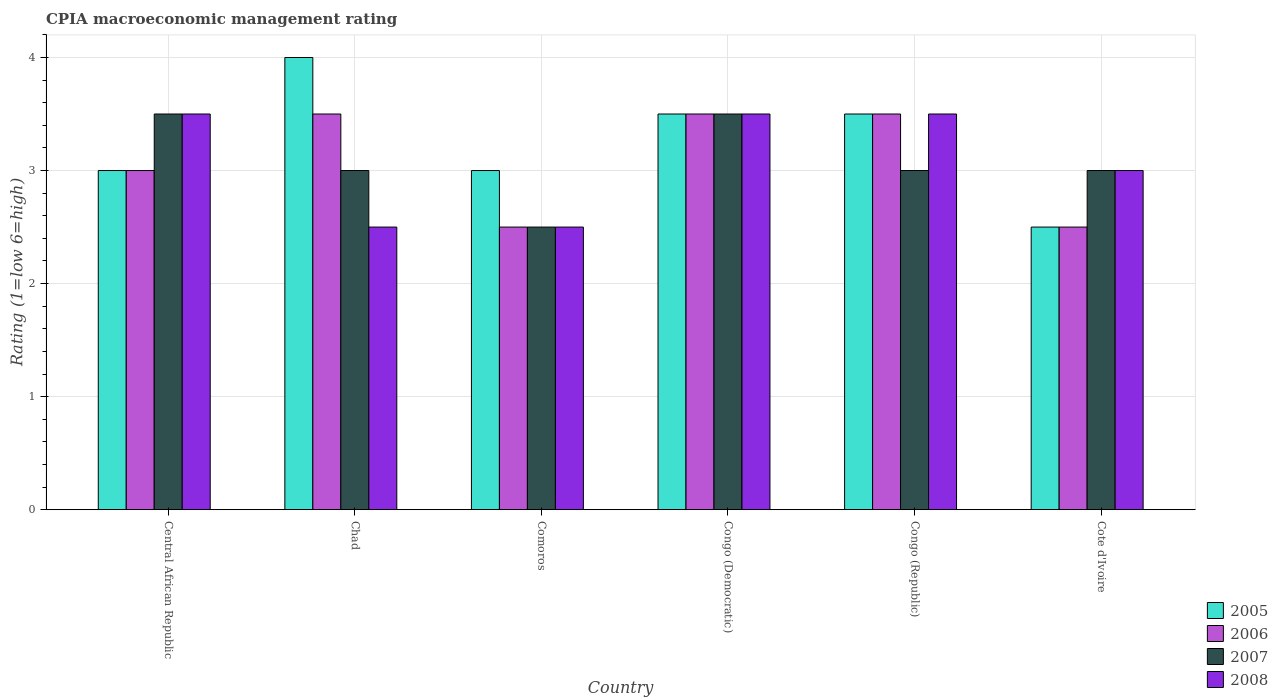Are the number of bars per tick equal to the number of legend labels?
Offer a terse response. Yes. Are the number of bars on each tick of the X-axis equal?
Offer a very short reply. Yes. How many bars are there on the 5th tick from the left?
Keep it short and to the point. 4. What is the label of the 2nd group of bars from the left?
Offer a very short reply. Chad. In how many cases, is the number of bars for a given country not equal to the number of legend labels?
Ensure brevity in your answer.  0. What is the CPIA rating in 2008 in Central African Republic?
Your response must be concise. 3.5. Across all countries, what is the minimum CPIA rating in 2005?
Provide a succinct answer. 2.5. In which country was the CPIA rating in 2005 maximum?
Offer a terse response. Chad. In which country was the CPIA rating in 2006 minimum?
Ensure brevity in your answer.  Comoros. What is the total CPIA rating in 2007 in the graph?
Offer a very short reply. 18.5. What is the average CPIA rating in 2005 per country?
Offer a very short reply. 3.25. In how many countries, is the CPIA rating in 2008 greater than 1?
Your answer should be compact. 6. What is the ratio of the CPIA rating in 2005 in Congo (Democratic) to that in Cote d'Ivoire?
Make the answer very short. 1.4. Is the CPIA rating in 2005 in Chad less than that in Comoros?
Provide a succinct answer. No. Is the difference between the CPIA rating in 2007 in Chad and Congo (Republic) greater than the difference between the CPIA rating in 2006 in Chad and Congo (Republic)?
Make the answer very short. No. Is it the case that in every country, the sum of the CPIA rating in 2007 and CPIA rating in 2008 is greater than the sum of CPIA rating in 2005 and CPIA rating in 2006?
Make the answer very short. No. What does the 2nd bar from the left in Congo (Democratic) represents?
Keep it short and to the point. 2006. What does the 4th bar from the right in Cote d'Ivoire represents?
Keep it short and to the point. 2005. Is it the case that in every country, the sum of the CPIA rating in 2006 and CPIA rating in 2008 is greater than the CPIA rating in 2007?
Provide a succinct answer. Yes. How many bars are there?
Keep it short and to the point. 24. How many countries are there in the graph?
Provide a succinct answer. 6. Are the values on the major ticks of Y-axis written in scientific E-notation?
Offer a terse response. No. Does the graph contain any zero values?
Your answer should be compact. No. Does the graph contain grids?
Your answer should be compact. Yes. How many legend labels are there?
Keep it short and to the point. 4. What is the title of the graph?
Provide a short and direct response. CPIA macroeconomic management rating. What is the Rating (1=low 6=high) in 2008 in Central African Republic?
Provide a short and direct response. 3.5. What is the Rating (1=low 6=high) in 2005 in Chad?
Provide a succinct answer. 4. What is the Rating (1=low 6=high) of 2006 in Chad?
Provide a succinct answer. 3.5. What is the Rating (1=low 6=high) of 2008 in Chad?
Give a very brief answer. 2.5. What is the Rating (1=low 6=high) of 2005 in Comoros?
Keep it short and to the point. 3. What is the Rating (1=low 6=high) in 2007 in Comoros?
Give a very brief answer. 2.5. What is the Rating (1=low 6=high) in 2008 in Congo (Democratic)?
Offer a terse response. 3.5. What is the Rating (1=low 6=high) in 2005 in Congo (Republic)?
Offer a terse response. 3.5. What is the Rating (1=low 6=high) of 2008 in Congo (Republic)?
Provide a succinct answer. 3.5. What is the Rating (1=low 6=high) of 2005 in Cote d'Ivoire?
Your answer should be compact. 2.5. What is the Rating (1=low 6=high) of 2006 in Cote d'Ivoire?
Your response must be concise. 2.5. What is the Rating (1=low 6=high) in 2007 in Cote d'Ivoire?
Offer a very short reply. 3. Across all countries, what is the maximum Rating (1=low 6=high) of 2007?
Ensure brevity in your answer.  3.5. Across all countries, what is the maximum Rating (1=low 6=high) of 2008?
Provide a succinct answer. 3.5. Across all countries, what is the minimum Rating (1=low 6=high) of 2006?
Make the answer very short. 2.5. Across all countries, what is the minimum Rating (1=low 6=high) in 2007?
Keep it short and to the point. 2.5. Across all countries, what is the minimum Rating (1=low 6=high) of 2008?
Give a very brief answer. 2.5. What is the difference between the Rating (1=low 6=high) in 2005 in Central African Republic and that in Comoros?
Give a very brief answer. 0. What is the difference between the Rating (1=low 6=high) of 2006 in Central African Republic and that in Comoros?
Ensure brevity in your answer.  0.5. What is the difference between the Rating (1=low 6=high) in 2007 in Central African Republic and that in Comoros?
Provide a short and direct response. 1. What is the difference between the Rating (1=low 6=high) of 2005 in Central African Republic and that in Congo (Democratic)?
Keep it short and to the point. -0.5. What is the difference between the Rating (1=low 6=high) of 2007 in Central African Republic and that in Congo (Democratic)?
Ensure brevity in your answer.  0. What is the difference between the Rating (1=low 6=high) in 2006 in Central African Republic and that in Congo (Republic)?
Keep it short and to the point. -0.5. What is the difference between the Rating (1=low 6=high) of 2007 in Central African Republic and that in Congo (Republic)?
Provide a succinct answer. 0.5. What is the difference between the Rating (1=low 6=high) of 2008 in Central African Republic and that in Congo (Republic)?
Your answer should be compact. 0. What is the difference between the Rating (1=low 6=high) of 2005 in Chad and that in Comoros?
Your answer should be very brief. 1. What is the difference between the Rating (1=low 6=high) in 2006 in Chad and that in Comoros?
Make the answer very short. 1. What is the difference between the Rating (1=low 6=high) in 2007 in Chad and that in Comoros?
Provide a succinct answer. 0.5. What is the difference between the Rating (1=low 6=high) in 2006 in Chad and that in Congo (Democratic)?
Your answer should be compact. 0. What is the difference between the Rating (1=low 6=high) in 2007 in Chad and that in Congo (Democratic)?
Keep it short and to the point. -0.5. What is the difference between the Rating (1=low 6=high) of 2005 in Chad and that in Congo (Republic)?
Make the answer very short. 0.5. What is the difference between the Rating (1=low 6=high) in 2007 in Chad and that in Congo (Republic)?
Provide a short and direct response. 0. What is the difference between the Rating (1=low 6=high) in 2006 in Chad and that in Cote d'Ivoire?
Offer a terse response. 1. What is the difference between the Rating (1=low 6=high) in 2006 in Comoros and that in Congo (Democratic)?
Provide a short and direct response. -1. What is the difference between the Rating (1=low 6=high) of 2007 in Comoros and that in Congo (Democratic)?
Offer a very short reply. -1. What is the difference between the Rating (1=low 6=high) in 2005 in Comoros and that in Congo (Republic)?
Provide a succinct answer. -0.5. What is the difference between the Rating (1=low 6=high) of 2006 in Comoros and that in Congo (Republic)?
Provide a succinct answer. -1. What is the difference between the Rating (1=low 6=high) of 2008 in Comoros and that in Congo (Republic)?
Ensure brevity in your answer.  -1. What is the difference between the Rating (1=low 6=high) of 2007 in Comoros and that in Cote d'Ivoire?
Keep it short and to the point. -0.5. What is the difference between the Rating (1=low 6=high) in 2008 in Congo (Democratic) and that in Congo (Republic)?
Your response must be concise. 0. What is the difference between the Rating (1=low 6=high) in 2005 in Congo (Democratic) and that in Cote d'Ivoire?
Keep it short and to the point. 1. What is the difference between the Rating (1=low 6=high) of 2007 in Congo (Democratic) and that in Cote d'Ivoire?
Your response must be concise. 0.5. What is the difference between the Rating (1=low 6=high) of 2005 in Congo (Republic) and that in Cote d'Ivoire?
Ensure brevity in your answer.  1. What is the difference between the Rating (1=low 6=high) of 2007 in Congo (Republic) and that in Cote d'Ivoire?
Provide a short and direct response. 0. What is the difference between the Rating (1=low 6=high) in 2008 in Congo (Republic) and that in Cote d'Ivoire?
Keep it short and to the point. 0.5. What is the difference between the Rating (1=low 6=high) in 2005 in Central African Republic and the Rating (1=low 6=high) in 2008 in Chad?
Ensure brevity in your answer.  0.5. What is the difference between the Rating (1=low 6=high) of 2007 in Central African Republic and the Rating (1=low 6=high) of 2008 in Chad?
Your response must be concise. 1. What is the difference between the Rating (1=low 6=high) in 2005 in Central African Republic and the Rating (1=low 6=high) in 2007 in Comoros?
Your answer should be very brief. 0.5. What is the difference between the Rating (1=low 6=high) in 2006 in Central African Republic and the Rating (1=low 6=high) in 2008 in Comoros?
Keep it short and to the point. 0.5. What is the difference between the Rating (1=low 6=high) in 2007 in Central African Republic and the Rating (1=low 6=high) in 2008 in Comoros?
Keep it short and to the point. 1. What is the difference between the Rating (1=low 6=high) of 2005 in Central African Republic and the Rating (1=low 6=high) of 2006 in Congo (Democratic)?
Your answer should be very brief. -0.5. What is the difference between the Rating (1=low 6=high) in 2005 in Central African Republic and the Rating (1=low 6=high) in 2007 in Congo (Democratic)?
Keep it short and to the point. -0.5. What is the difference between the Rating (1=low 6=high) in 2005 in Central African Republic and the Rating (1=low 6=high) in 2006 in Congo (Republic)?
Your answer should be very brief. -0.5. What is the difference between the Rating (1=low 6=high) in 2005 in Central African Republic and the Rating (1=low 6=high) in 2007 in Congo (Republic)?
Your response must be concise. 0. What is the difference between the Rating (1=low 6=high) of 2005 in Central African Republic and the Rating (1=low 6=high) of 2008 in Congo (Republic)?
Provide a short and direct response. -0.5. What is the difference between the Rating (1=low 6=high) in 2006 in Central African Republic and the Rating (1=low 6=high) in 2007 in Congo (Republic)?
Keep it short and to the point. 0. What is the difference between the Rating (1=low 6=high) in 2006 in Central African Republic and the Rating (1=low 6=high) in 2008 in Congo (Republic)?
Keep it short and to the point. -0.5. What is the difference between the Rating (1=low 6=high) in 2005 in Central African Republic and the Rating (1=low 6=high) in 2006 in Cote d'Ivoire?
Keep it short and to the point. 0.5. What is the difference between the Rating (1=low 6=high) in 2005 in Central African Republic and the Rating (1=low 6=high) in 2007 in Cote d'Ivoire?
Your response must be concise. 0. What is the difference between the Rating (1=low 6=high) of 2006 in Central African Republic and the Rating (1=low 6=high) of 2008 in Cote d'Ivoire?
Keep it short and to the point. 0. What is the difference between the Rating (1=low 6=high) in 2007 in Central African Republic and the Rating (1=low 6=high) in 2008 in Cote d'Ivoire?
Give a very brief answer. 0.5. What is the difference between the Rating (1=low 6=high) in 2005 in Chad and the Rating (1=low 6=high) in 2006 in Comoros?
Your answer should be very brief. 1.5. What is the difference between the Rating (1=low 6=high) in 2006 in Chad and the Rating (1=low 6=high) in 2008 in Comoros?
Your answer should be compact. 1. What is the difference between the Rating (1=low 6=high) of 2007 in Chad and the Rating (1=low 6=high) of 2008 in Comoros?
Provide a short and direct response. 0.5. What is the difference between the Rating (1=low 6=high) of 2005 in Chad and the Rating (1=low 6=high) of 2007 in Congo (Democratic)?
Provide a short and direct response. 0.5. What is the difference between the Rating (1=low 6=high) in 2006 in Chad and the Rating (1=low 6=high) in 2007 in Congo (Democratic)?
Your response must be concise. 0. What is the difference between the Rating (1=low 6=high) of 2007 in Chad and the Rating (1=low 6=high) of 2008 in Congo (Democratic)?
Offer a very short reply. -0.5. What is the difference between the Rating (1=low 6=high) of 2007 in Chad and the Rating (1=low 6=high) of 2008 in Congo (Republic)?
Make the answer very short. -0.5. What is the difference between the Rating (1=low 6=high) of 2005 in Chad and the Rating (1=low 6=high) of 2006 in Cote d'Ivoire?
Your response must be concise. 1.5. What is the difference between the Rating (1=low 6=high) in 2007 in Chad and the Rating (1=low 6=high) in 2008 in Cote d'Ivoire?
Keep it short and to the point. 0. What is the difference between the Rating (1=low 6=high) of 2005 in Comoros and the Rating (1=low 6=high) of 2007 in Congo (Democratic)?
Ensure brevity in your answer.  -0.5. What is the difference between the Rating (1=low 6=high) in 2006 in Comoros and the Rating (1=low 6=high) in 2008 in Congo (Democratic)?
Your answer should be very brief. -1. What is the difference between the Rating (1=low 6=high) in 2005 in Comoros and the Rating (1=low 6=high) in 2007 in Congo (Republic)?
Provide a succinct answer. 0. What is the difference between the Rating (1=low 6=high) of 2006 in Comoros and the Rating (1=low 6=high) of 2008 in Congo (Republic)?
Provide a short and direct response. -1. What is the difference between the Rating (1=low 6=high) of 2007 in Comoros and the Rating (1=low 6=high) of 2008 in Congo (Republic)?
Offer a very short reply. -1. What is the difference between the Rating (1=low 6=high) of 2005 in Comoros and the Rating (1=low 6=high) of 2007 in Cote d'Ivoire?
Keep it short and to the point. 0. What is the difference between the Rating (1=low 6=high) of 2005 in Comoros and the Rating (1=low 6=high) of 2008 in Cote d'Ivoire?
Your answer should be very brief. 0. What is the difference between the Rating (1=low 6=high) of 2006 in Comoros and the Rating (1=low 6=high) of 2007 in Cote d'Ivoire?
Your answer should be compact. -0.5. What is the difference between the Rating (1=low 6=high) in 2006 in Comoros and the Rating (1=low 6=high) in 2008 in Cote d'Ivoire?
Provide a short and direct response. -0.5. What is the difference between the Rating (1=low 6=high) in 2005 in Congo (Democratic) and the Rating (1=low 6=high) in 2006 in Congo (Republic)?
Keep it short and to the point. 0. What is the difference between the Rating (1=low 6=high) in 2005 in Congo (Democratic) and the Rating (1=low 6=high) in 2008 in Congo (Republic)?
Your answer should be very brief. 0. What is the difference between the Rating (1=low 6=high) of 2007 in Congo (Democratic) and the Rating (1=low 6=high) of 2008 in Congo (Republic)?
Offer a terse response. 0. What is the difference between the Rating (1=low 6=high) in 2005 in Congo (Democratic) and the Rating (1=low 6=high) in 2006 in Cote d'Ivoire?
Keep it short and to the point. 1. What is the difference between the Rating (1=low 6=high) in 2005 in Congo (Republic) and the Rating (1=low 6=high) in 2006 in Cote d'Ivoire?
Your response must be concise. 1. What is the difference between the Rating (1=low 6=high) of 2006 in Congo (Republic) and the Rating (1=low 6=high) of 2007 in Cote d'Ivoire?
Your response must be concise. 0.5. What is the difference between the Rating (1=low 6=high) in 2006 in Congo (Republic) and the Rating (1=low 6=high) in 2008 in Cote d'Ivoire?
Offer a terse response. 0.5. What is the difference between the Rating (1=low 6=high) in 2007 in Congo (Republic) and the Rating (1=low 6=high) in 2008 in Cote d'Ivoire?
Keep it short and to the point. 0. What is the average Rating (1=low 6=high) in 2006 per country?
Provide a succinct answer. 3.08. What is the average Rating (1=low 6=high) in 2007 per country?
Your answer should be compact. 3.08. What is the average Rating (1=low 6=high) of 2008 per country?
Your response must be concise. 3.08. What is the difference between the Rating (1=low 6=high) in 2005 and Rating (1=low 6=high) in 2006 in Central African Republic?
Offer a very short reply. 0. What is the difference between the Rating (1=low 6=high) of 2005 and Rating (1=low 6=high) of 2008 in Central African Republic?
Give a very brief answer. -0.5. What is the difference between the Rating (1=low 6=high) in 2006 and Rating (1=low 6=high) in 2007 in Central African Republic?
Make the answer very short. -0.5. What is the difference between the Rating (1=low 6=high) of 2006 and Rating (1=low 6=high) of 2008 in Central African Republic?
Your answer should be very brief. -0.5. What is the difference between the Rating (1=low 6=high) in 2007 and Rating (1=low 6=high) in 2008 in Central African Republic?
Keep it short and to the point. 0. What is the difference between the Rating (1=low 6=high) in 2005 and Rating (1=low 6=high) in 2006 in Chad?
Make the answer very short. 0.5. What is the difference between the Rating (1=low 6=high) of 2005 and Rating (1=low 6=high) of 2008 in Chad?
Provide a succinct answer. 1.5. What is the difference between the Rating (1=low 6=high) in 2006 and Rating (1=low 6=high) in 2008 in Chad?
Offer a very short reply. 1. What is the difference between the Rating (1=low 6=high) of 2005 and Rating (1=low 6=high) of 2006 in Comoros?
Your answer should be very brief. 0.5. What is the difference between the Rating (1=low 6=high) in 2005 and Rating (1=low 6=high) in 2007 in Comoros?
Ensure brevity in your answer.  0.5. What is the difference between the Rating (1=low 6=high) in 2006 and Rating (1=low 6=high) in 2007 in Comoros?
Provide a succinct answer. 0. What is the difference between the Rating (1=low 6=high) in 2005 and Rating (1=low 6=high) in 2006 in Congo (Democratic)?
Make the answer very short. 0. What is the difference between the Rating (1=low 6=high) of 2005 and Rating (1=low 6=high) of 2007 in Congo (Democratic)?
Your answer should be compact. 0. What is the difference between the Rating (1=low 6=high) in 2006 and Rating (1=low 6=high) in 2008 in Congo (Democratic)?
Your answer should be very brief. 0. What is the difference between the Rating (1=low 6=high) in 2006 and Rating (1=low 6=high) in 2007 in Congo (Republic)?
Offer a very short reply. 0.5. What is the difference between the Rating (1=low 6=high) in 2007 and Rating (1=low 6=high) in 2008 in Congo (Republic)?
Your answer should be compact. -0.5. What is the difference between the Rating (1=low 6=high) of 2005 and Rating (1=low 6=high) of 2007 in Cote d'Ivoire?
Provide a short and direct response. -0.5. What is the difference between the Rating (1=low 6=high) of 2006 and Rating (1=low 6=high) of 2007 in Cote d'Ivoire?
Make the answer very short. -0.5. What is the difference between the Rating (1=low 6=high) of 2006 and Rating (1=low 6=high) of 2008 in Cote d'Ivoire?
Provide a succinct answer. -0.5. What is the difference between the Rating (1=low 6=high) of 2007 and Rating (1=low 6=high) of 2008 in Cote d'Ivoire?
Your answer should be compact. 0. What is the ratio of the Rating (1=low 6=high) of 2006 in Central African Republic to that in Chad?
Ensure brevity in your answer.  0.86. What is the ratio of the Rating (1=low 6=high) in 2008 in Central African Republic to that in Chad?
Give a very brief answer. 1.4. What is the ratio of the Rating (1=low 6=high) in 2006 in Central African Republic to that in Comoros?
Ensure brevity in your answer.  1.2. What is the ratio of the Rating (1=low 6=high) of 2008 in Central African Republic to that in Comoros?
Your answer should be compact. 1.4. What is the ratio of the Rating (1=low 6=high) of 2005 in Central African Republic to that in Congo (Democratic)?
Your response must be concise. 0.86. What is the ratio of the Rating (1=low 6=high) of 2006 in Central African Republic to that in Congo (Democratic)?
Your answer should be compact. 0.86. What is the ratio of the Rating (1=low 6=high) of 2005 in Central African Republic to that in Congo (Republic)?
Keep it short and to the point. 0.86. What is the ratio of the Rating (1=low 6=high) in 2007 in Central African Republic to that in Congo (Republic)?
Make the answer very short. 1.17. What is the ratio of the Rating (1=low 6=high) in 2006 in Central African Republic to that in Cote d'Ivoire?
Offer a very short reply. 1.2. What is the ratio of the Rating (1=low 6=high) of 2007 in Central African Republic to that in Cote d'Ivoire?
Your answer should be compact. 1.17. What is the ratio of the Rating (1=low 6=high) in 2005 in Chad to that in Comoros?
Provide a succinct answer. 1.33. What is the ratio of the Rating (1=low 6=high) of 2007 in Chad to that in Comoros?
Keep it short and to the point. 1.2. What is the ratio of the Rating (1=low 6=high) of 2008 in Chad to that in Comoros?
Provide a succinct answer. 1. What is the ratio of the Rating (1=low 6=high) of 2007 in Chad to that in Congo (Democratic)?
Offer a terse response. 0.86. What is the ratio of the Rating (1=low 6=high) in 2008 in Chad to that in Congo (Democratic)?
Your response must be concise. 0.71. What is the ratio of the Rating (1=low 6=high) in 2006 in Chad to that in Congo (Republic)?
Ensure brevity in your answer.  1. What is the ratio of the Rating (1=low 6=high) of 2007 in Chad to that in Cote d'Ivoire?
Ensure brevity in your answer.  1. What is the ratio of the Rating (1=low 6=high) in 2005 in Comoros to that in Congo (Democratic)?
Offer a very short reply. 0.86. What is the ratio of the Rating (1=low 6=high) of 2006 in Comoros to that in Congo (Democratic)?
Provide a short and direct response. 0.71. What is the ratio of the Rating (1=low 6=high) of 2006 in Comoros to that in Congo (Republic)?
Offer a terse response. 0.71. What is the ratio of the Rating (1=low 6=high) in 2007 in Comoros to that in Congo (Republic)?
Provide a short and direct response. 0.83. What is the ratio of the Rating (1=low 6=high) of 2006 in Comoros to that in Cote d'Ivoire?
Offer a very short reply. 1. What is the ratio of the Rating (1=low 6=high) of 2007 in Comoros to that in Cote d'Ivoire?
Provide a short and direct response. 0.83. What is the ratio of the Rating (1=low 6=high) in 2005 in Congo (Democratic) to that in Congo (Republic)?
Your answer should be very brief. 1. What is the ratio of the Rating (1=low 6=high) of 2006 in Congo (Democratic) to that in Congo (Republic)?
Offer a very short reply. 1. What is the ratio of the Rating (1=low 6=high) in 2007 in Congo (Democratic) to that in Congo (Republic)?
Offer a terse response. 1.17. What is the ratio of the Rating (1=low 6=high) of 2008 in Congo (Democratic) to that in Cote d'Ivoire?
Your response must be concise. 1.17. What is the ratio of the Rating (1=low 6=high) in 2006 in Congo (Republic) to that in Cote d'Ivoire?
Provide a succinct answer. 1.4. What is the ratio of the Rating (1=low 6=high) in 2007 in Congo (Republic) to that in Cote d'Ivoire?
Provide a short and direct response. 1. What is the difference between the highest and the second highest Rating (1=low 6=high) of 2008?
Provide a short and direct response. 0. What is the difference between the highest and the lowest Rating (1=low 6=high) of 2005?
Your answer should be very brief. 1.5. What is the difference between the highest and the lowest Rating (1=low 6=high) in 2006?
Provide a succinct answer. 1. 